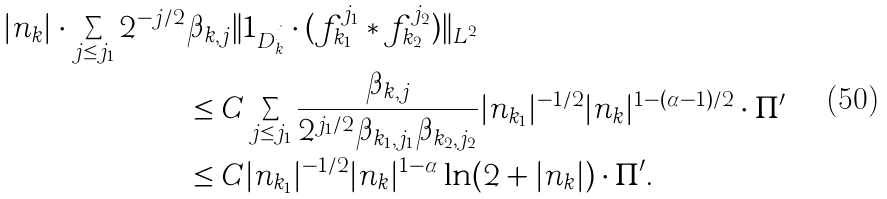<formula> <loc_0><loc_0><loc_500><loc_500>| n _ { k } | \cdot \sum _ { j \leq j _ { 1 } } 2 ^ { - j / 2 } & \beta _ { k , j } \| 1 _ { D _ { k } ^ { j } } \cdot ( f _ { k _ { 1 } } ^ { j _ { 1 } } \ast f _ { k _ { 2 } } ^ { j _ { 2 } } ) \| _ { L ^ { 2 } } \\ & \leq C \sum _ { j \leq j _ { 1 } } \frac { \beta _ { k , j } } { 2 ^ { j _ { 1 } / 2 } \beta _ { k _ { 1 } , j _ { 1 } } \beta _ { k _ { 2 } , j _ { 2 } } } | n _ { k _ { 1 } } | ^ { - 1 / 2 } | n _ { k } | ^ { 1 - ( \alpha - 1 ) / 2 } \cdot \Pi ^ { \prime } \\ & \leq C | n _ { k _ { 1 } } | ^ { - 1 / 2 } | n _ { k } | ^ { 1 - \alpha } \ln ( 2 + | n _ { k } | ) \cdot \Pi ^ { \prime } .</formula> 